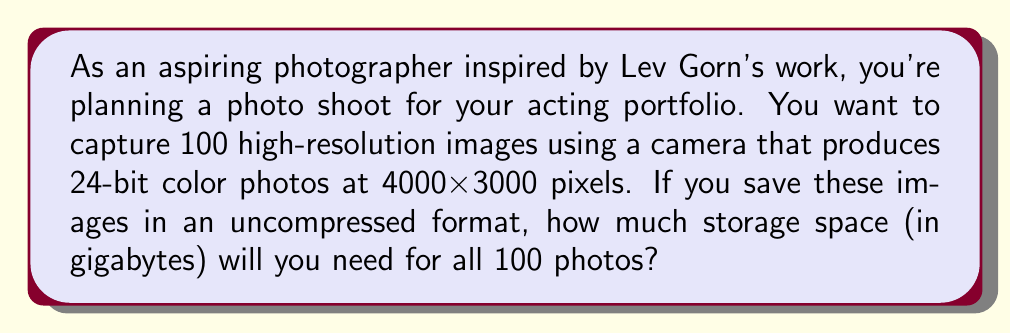Give your solution to this math problem. Let's break this down step-by-step:

1) First, we need to calculate the number of pixels in each image:
   $4000 \times 3000 = 12,000,000$ pixels per image

2) Each pixel uses 24 bits of color information:
   $24 \text{ bits} = 3 \text{ bytes}$ (since 1 byte = 8 bits)

3) So, the size of each image in bytes is:
   $12,000,000 \text{ pixels} \times 3 \text{ bytes/pixel} = 36,000,000 \text{ bytes}$

4) Convert bytes to gigabytes:
   $36,000,000 \text{ bytes} = 36 \text{ MB} = 0.036 \text{ GB}$

5) For 100 images:
   $0.036 \text{ GB} \times 100 = 3.6 \text{ GB}$

Therefore, the total storage space needed for 100 uncompressed high-resolution photos is 3.6 GB.

Note: In reality, most digital cameras use compressed formats like JPEG by default, which would significantly reduce the required storage space. However, for maximum quality in a professional portfolio, uncompressed formats might be preferred.
Answer: 3.6 GB 